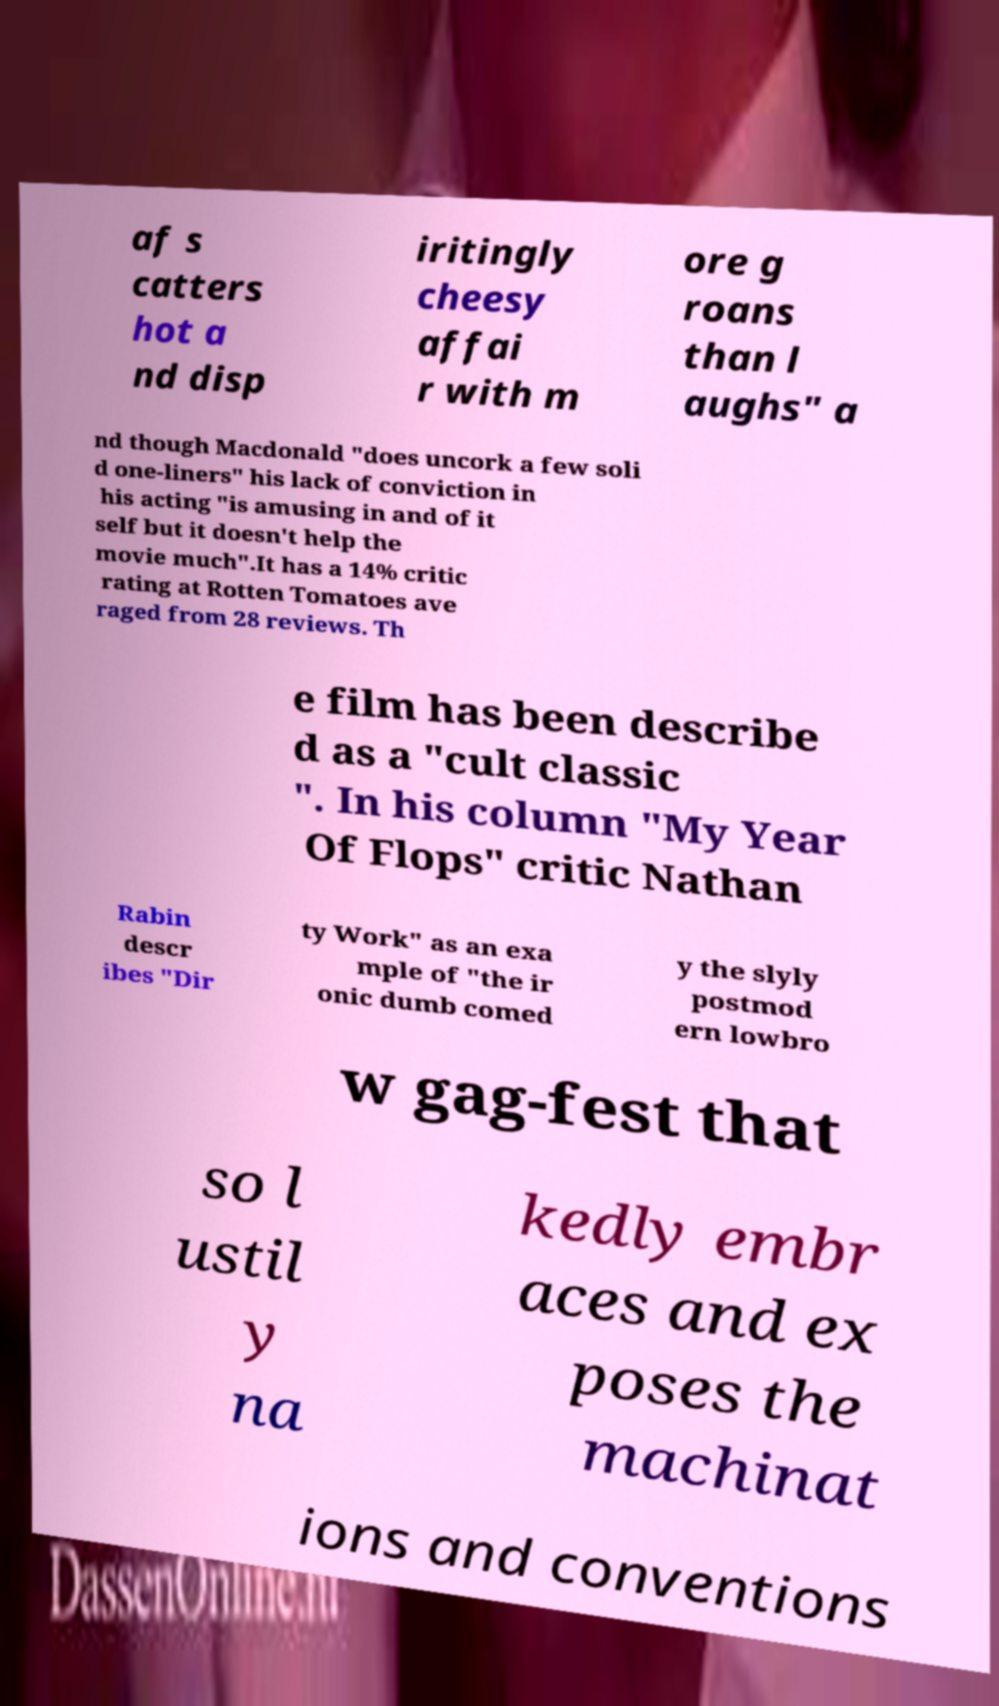Could you assist in decoding the text presented in this image and type it out clearly? af s catters hot a nd disp iritingly cheesy affai r with m ore g roans than l aughs" a nd though Macdonald "does uncork a few soli d one-liners" his lack of conviction in his acting "is amusing in and of it self but it doesn't help the movie much".It has a 14% critic rating at Rotten Tomatoes ave raged from 28 reviews. Th e film has been describe d as a "cult classic ". In his column "My Year Of Flops" critic Nathan Rabin descr ibes "Dir ty Work" as an exa mple of "the ir onic dumb comed y the slyly postmod ern lowbro w gag-fest that so l ustil y na kedly embr aces and ex poses the machinat ions and conventions 